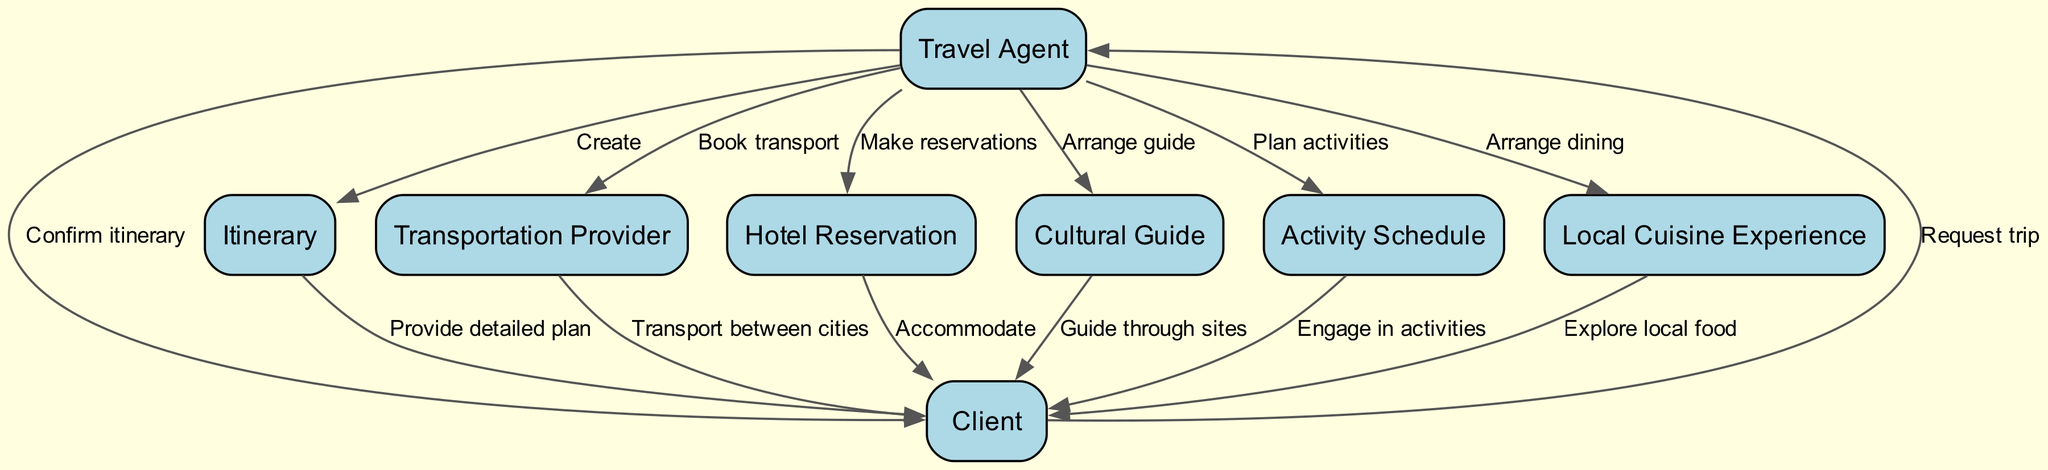What is the role of the Travel Agent in the itinerary management? The Travel Agent is responsible for managing the entire itinerary by creating the plan, booking transportation and accommodation, arranging for cultural guides, and organizing activities.
Answer: Managing the entire itinerary How many main elements are involved in the diagram? The diagram contains eight main elements including Travel Agent, Client, Itinerary, Transportation Provider, Hotel Reservation, Cultural Guide, Activity Schedule, and Local Cuisine Experience.
Answer: Eight Who provides transport between cities? The Transportation Provider is the entity responsible for transporting clients between cities and attractions during the trip.
Answer: Transportation Provider What is the first step taken by the Client? The first step taken by the Client is to request the trip from the Travel Agent.
Answer: Request trip What is the last confirmation the Travel Agent provides to the Client? The last confirmation provided by the Travel Agent to the Client is the confirmation of the itinerary details after all arrangements are made.
Answer: Confirm itinerary How does the Cultural Guide interact with the Client? The Cultural Guide interacts with the Client by guiding them through historical sites during the trip, providing insights and knowledge about the cultural heritage.
Answer: Guide through sites What is the relationship between the Itinerary and the Client? The Itinerary provides a detailed plan to the Client, ensuring they understand the schedule and arrangements for the trip.
Answer: Provide detailed plan What additional experience is arranged for the Client aside from cultural activities? The Local Cuisine Experience is arranged, allowing the Client to explore local food through authentic dining experiences.
Answer: Local Cuisine Experience What type of activities are included in the itinerary? The itinerary includes engaging in planned activities such as visiting forts, palaces, and local markets, which contribute to the cultural exploration aspect.
Answer: Planned activities 